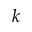Convert formula to latex. <formula><loc_0><loc_0><loc_500><loc_500>k</formula> 